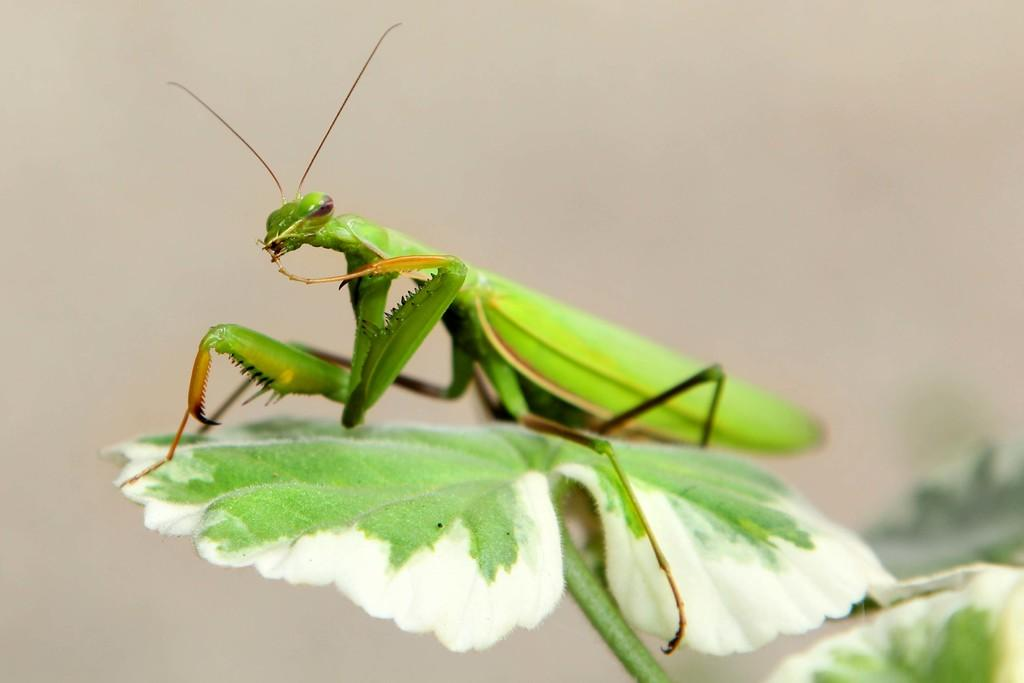What is the main subject of the image? There is an insect in the image. Where is the insect located? The insect is on a leaf. Can you describe the background of the image? The background of the image is blurred. What type of pencil is the insect using to draw on the leaf? There is no pencil present in the image, and insects do not use pencils to draw. 